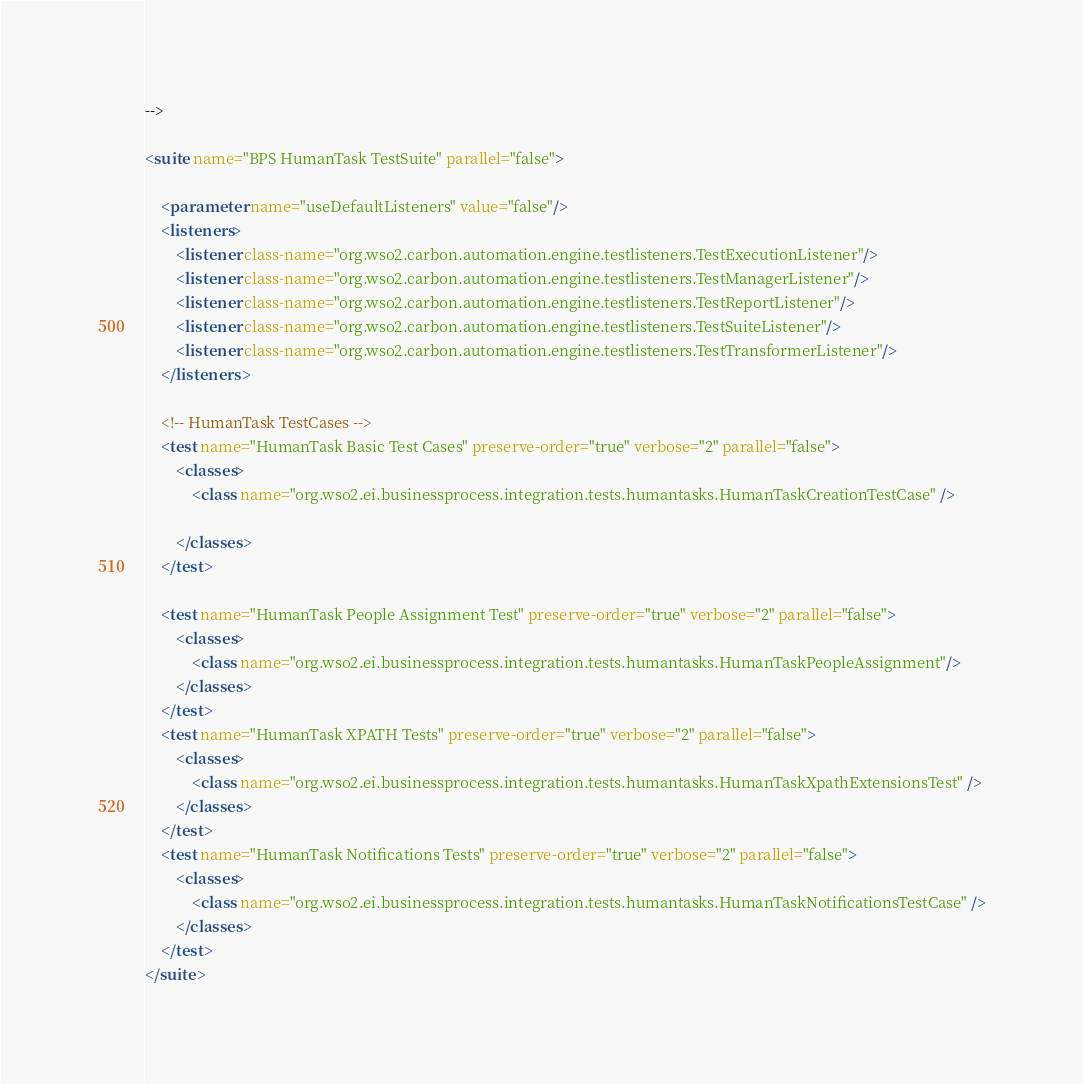Convert code to text. <code><loc_0><loc_0><loc_500><loc_500><_XML_>-->

<suite name="BPS HumanTask TestSuite" parallel="false">

    <parameter name="useDefaultListeners" value="false"/>
    <listeners>
        <listener class-name="org.wso2.carbon.automation.engine.testlisteners.TestExecutionListener"/>
        <listener class-name="org.wso2.carbon.automation.engine.testlisteners.TestManagerListener"/>
        <listener class-name="org.wso2.carbon.automation.engine.testlisteners.TestReportListener"/>
        <listener class-name="org.wso2.carbon.automation.engine.testlisteners.TestSuiteListener"/>
        <listener class-name="org.wso2.carbon.automation.engine.testlisteners.TestTransformerListener"/>
    </listeners>

    <!-- HumanTask TestCases -->
    <test name="HumanTask Basic Test Cases" preserve-order="true" verbose="2" parallel="false">
        <classes>
            <class name="org.wso2.ei.businessprocess.integration.tests.humantasks.HumanTaskCreationTestCase" />

        </classes>
    </test>

    <test name="HumanTask People Assignment Test" preserve-order="true" verbose="2" parallel="false">
        <classes>
            <class name="org.wso2.ei.businessprocess.integration.tests.humantasks.HumanTaskPeopleAssignment"/>
        </classes>
    </test>
    <test name="HumanTask XPATH Tests" preserve-order="true" verbose="2" parallel="false">
        <classes>
            <class name="org.wso2.ei.businessprocess.integration.tests.humantasks.HumanTaskXpathExtensionsTest" />
        </classes>
    </test>
    <test name="HumanTask Notifications Tests" preserve-order="true" verbose="2" parallel="false">
        <classes>
            <class name="org.wso2.ei.businessprocess.integration.tests.humantasks.HumanTaskNotificationsTestCase" />
        </classes>
    </test>
</suite>


</code> 